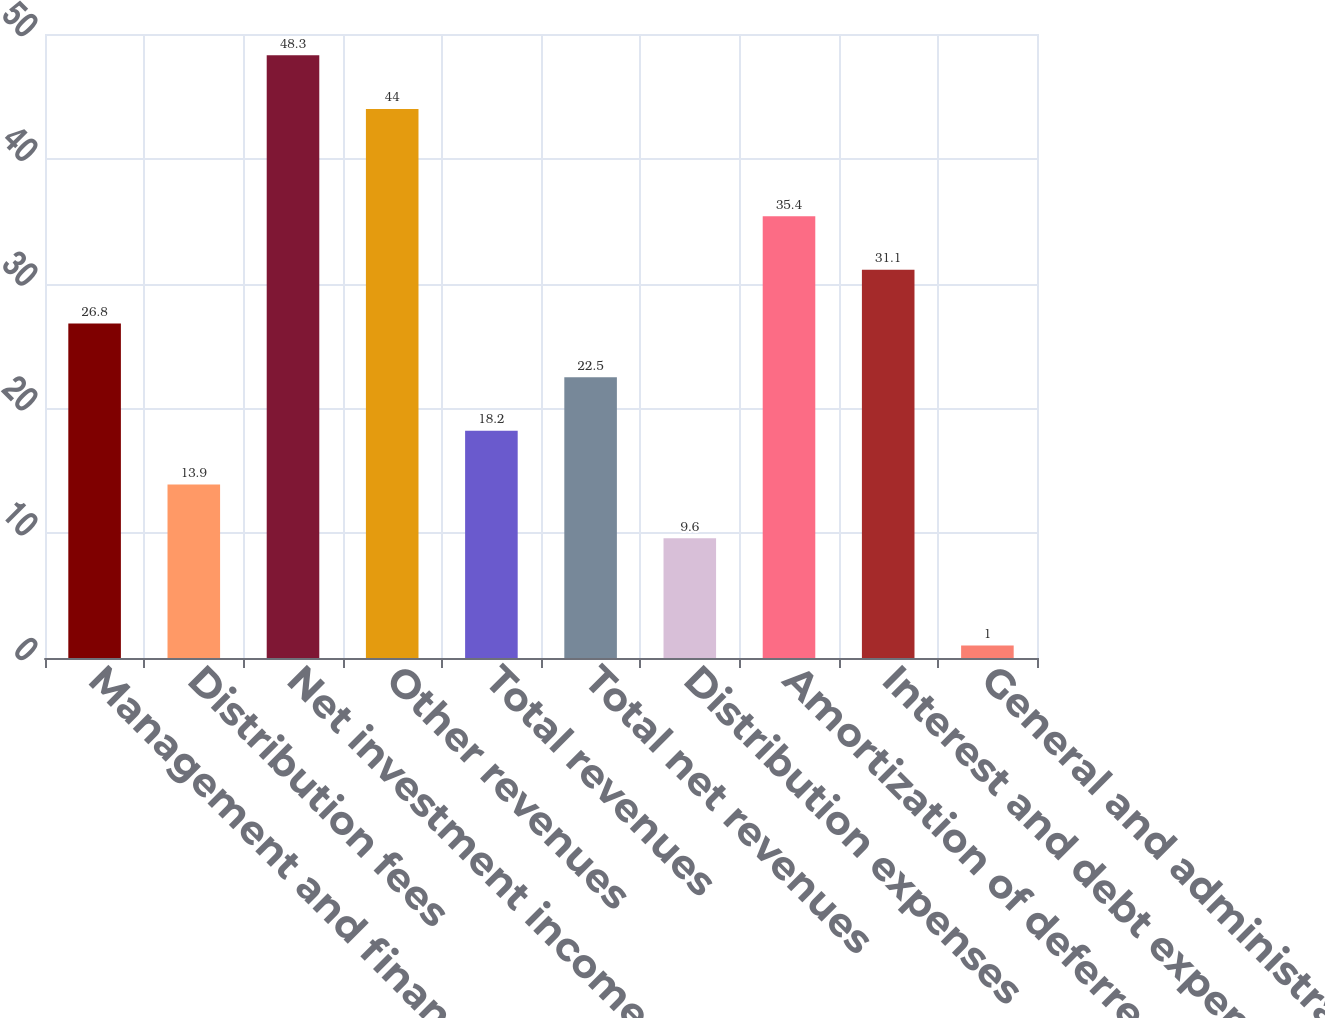Convert chart. <chart><loc_0><loc_0><loc_500><loc_500><bar_chart><fcel>Management and financial<fcel>Distribution fees<fcel>Net investment income<fcel>Other revenues<fcel>Total revenues<fcel>Total net revenues<fcel>Distribution expenses<fcel>Amortization of deferred<fcel>Interest and debt expense<fcel>General and administrative<nl><fcel>26.8<fcel>13.9<fcel>48.3<fcel>44<fcel>18.2<fcel>22.5<fcel>9.6<fcel>35.4<fcel>31.1<fcel>1<nl></chart> 